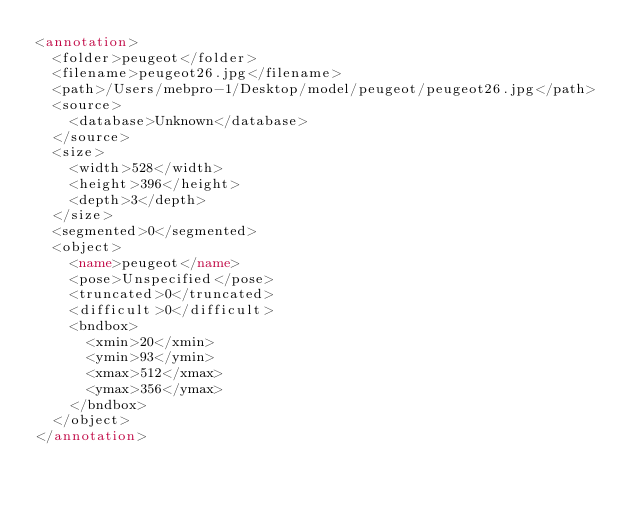<code> <loc_0><loc_0><loc_500><loc_500><_XML_><annotation>
	<folder>peugeot</folder>
	<filename>peugeot26.jpg</filename>
	<path>/Users/mebpro-1/Desktop/model/peugeot/peugeot26.jpg</path>
	<source>
		<database>Unknown</database>
	</source>
	<size>
		<width>528</width>
		<height>396</height>
		<depth>3</depth>
	</size>
	<segmented>0</segmented>
	<object>
		<name>peugeot</name>
		<pose>Unspecified</pose>
		<truncated>0</truncated>
		<difficult>0</difficult>
		<bndbox>
			<xmin>20</xmin>
			<ymin>93</ymin>
			<xmax>512</xmax>
			<ymax>356</ymax>
		</bndbox>
	</object>
</annotation>
</code> 